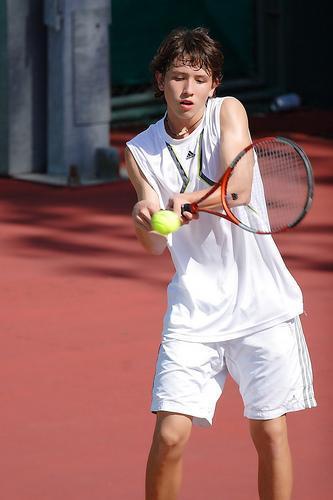How many people can you see?
Give a very brief answer. 1. How many round donuts have nuts on them in the image?
Give a very brief answer. 0. 